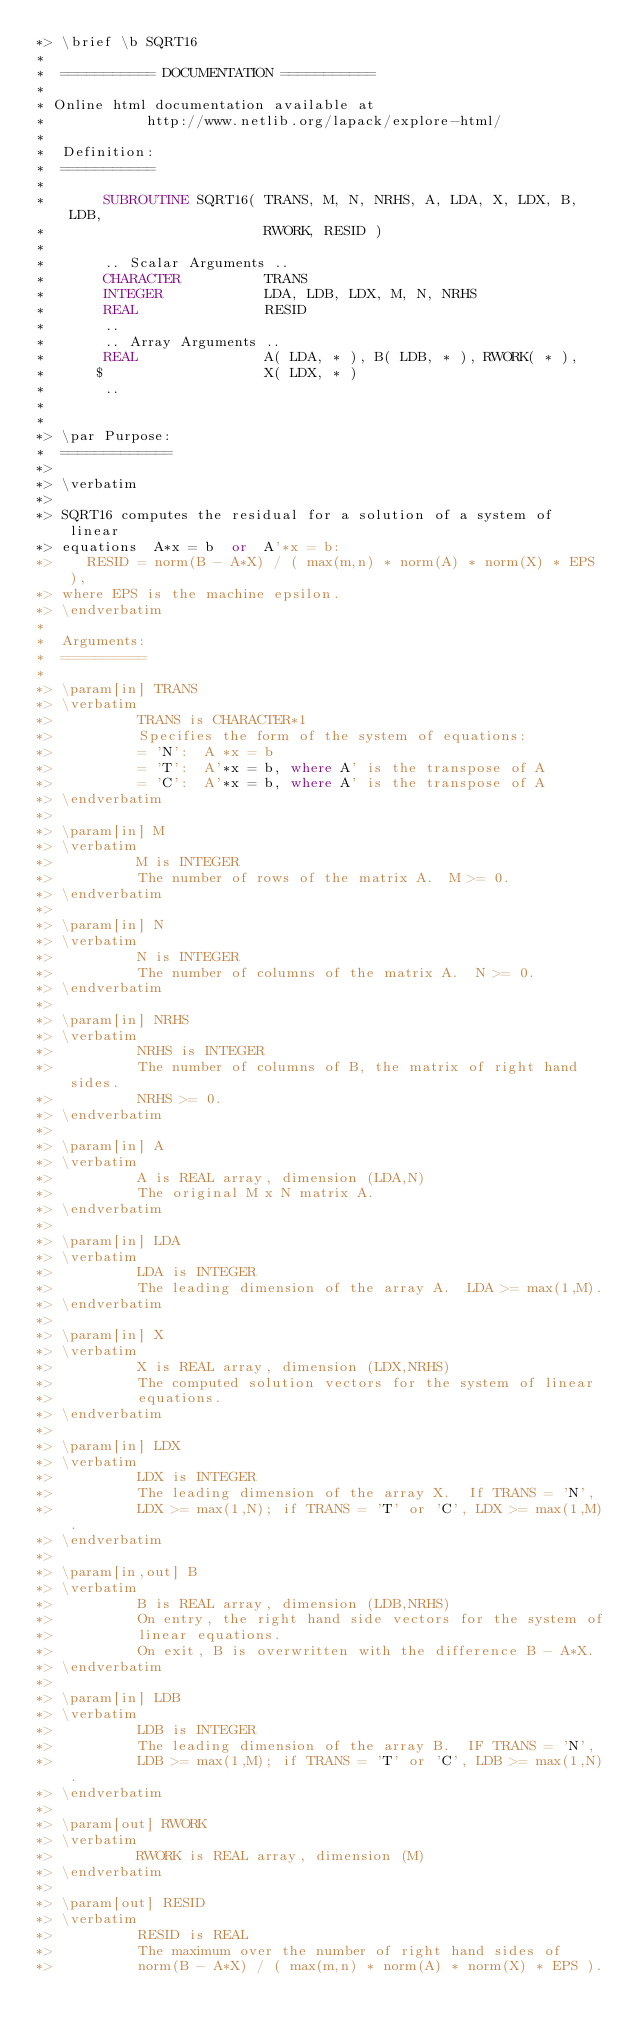<code> <loc_0><loc_0><loc_500><loc_500><_FORTRAN_>*> \brief \b SQRT16
*
*  =========== DOCUMENTATION ===========
*
* Online html documentation available at
*            http://www.netlib.org/lapack/explore-html/
*
*  Definition:
*  ===========
*
*       SUBROUTINE SQRT16( TRANS, M, N, NRHS, A, LDA, X, LDX, B, LDB,
*                          RWORK, RESID )
*
*       .. Scalar Arguments ..
*       CHARACTER          TRANS
*       INTEGER            LDA, LDB, LDX, M, N, NRHS
*       REAL               RESID
*       ..
*       .. Array Arguments ..
*       REAL               A( LDA, * ), B( LDB, * ), RWORK( * ),
*      $                   X( LDX, * )
*       ..
*
*
*> \par Purpose:
*  =============
*>
*> \verbatim
*>
*> SQRT16 computes the residual for a solution of a system of linear
*> equations  A*x = b  or  A'*x = b:
*>    RESID = norm(B - A*X) / ( max(m,n) * norm(A) * norm(X) * EPS ),
*> where EPS is the machine epsilon.
*> \endverbatim
*
*  Arguments:
*  ==========
*
*> \param[in] TRANS
*> \verbatim
*>          TRANS is CHARACTER*1
*>          Specifies the form of the system of equations:
*>          = 'N':  A *x = b
*>          = 'T':  A'*x = b, where A' is the transpose of A
*>          = 'C':  A'*x = b, where A' is the transpose of A
*> \endverbatim
*>
*> \param[in] M
*> \verbatim
*>          M is INTEGER
*>          The number of rows of the matrix A.  M >= 0.
*> \endverbatim
*>
*> \param[in] N
*> \verbatim
*>          N is INTEGER
*>          The number of columns of the matrix A.  N >= 0.
*> \endverbatim
*>
*> \param[in] NRHS
*> \verbatim
*>          NRHS is INTEGER
*>          The number of columns of B, the matrix of right hand sides.
*>          NRHS >= 0.
*> \endverbatim
*>
*> \param[in] A
*> \verbatim
*>          A is REAL array, dimension (LDA,N)
*>          The original M x N matrix A.
*> \endverbatim
*>
*> \param[in] LDA
*> \verbatim
*>          LDA is INTEGER
*>          The leading dimension of the array A.  LDA >= max(1,M).
*> \endverbatim
*>
*> \param[in] X
*> \verbatim
*>          X is REAL array, dimension (LDX,NRHS)
*>          The computed solution vectors for the system of linear
*>          equations.
*> \endverbatim
*>
*> \param[in] LDX
*> \verbatim
*>          LDX is INTEGER
*>          The leading dimension of the array X.  If TRANS = 'N',
*>          LDX >= max(1,N); if TRANS = 'T' or 'C', LDX >= max(1,M).
*> \endverbatim
*>
*> \param[in,out] B
*> \verbatim
*>          B is REAL array, dimension (LDB,NRHS)
*>          On entry, the right hand side vectors for the system of
*>          linear equations.
*>          On exit, B is overwritten with the difference B - A*X.
*> \endverbatim
*>
*> \param[in] LDB
*> \verbatim
*>          LDB is INTEGER
*>          The leading dimension of the array B.  IF TRANS = 'N',
*>          LDB >= max(1,M); if TRANS = 'T' or 'C', LDB >= max(1,N).
*> \endverbatim
*>
*> \param[out] RWORK
*> \verbatim
*>          RWORK is REAL array, dimension (M)
*> \endverbatim
*>
*> \param[out] RESID
*> \verbatim
*>          RESID is REAL
*>          The maximum over the number of right hand sides of
*>          norm(B - A*X) / ( max(m,n) * norm(A) * norm(X) * EPS ).</code> 